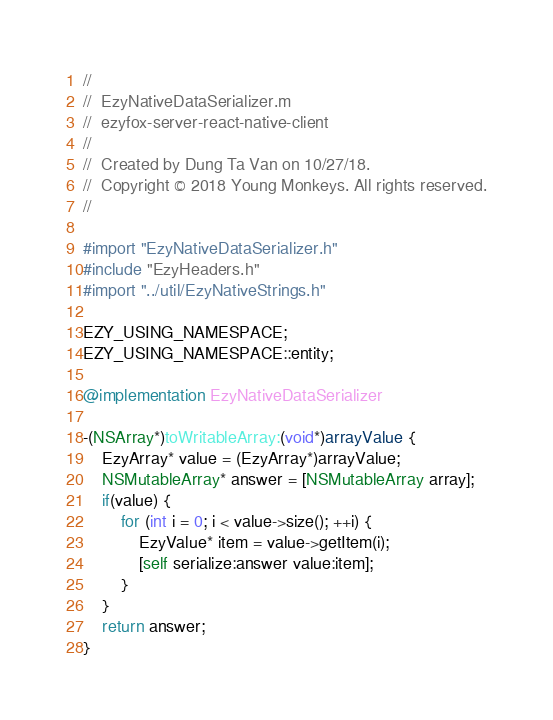<code> <loc_0><loc_0><loc_500><loc_500><_ObjectiveC_>//
//  EzyNativeDataSerializer.m
//  ezyfox-server-react-native-client
//
//  Created by Dung Ta Van on 10/27/18.
//  Copyright © 2018 Young Monkeys. All rights reserved.
//

#import "EzyNativeDataSerializer.h"
#include "EzyHeaders.h"
#import "../util/EzyNativeStrings.h"

EZY_USING_NAMESPACE;
EZY_USING_NAMESPACE::entity;

@implementation EzyNativeDataSerializer

-(NSArray*)toWritableArray:(void*)arrayValue {
    EzyArray* value = (EzyArray*)arrayValue;
    NSMutableArray* answer = [NSMutableArray array];
    if(value) {
        for (int i = 0; i < value->size(); ++i) {
            EzyValue* item = value->getItem(i);
            [self serialize:answer value:item];
        }
    }
    return answer;
}
</code> 